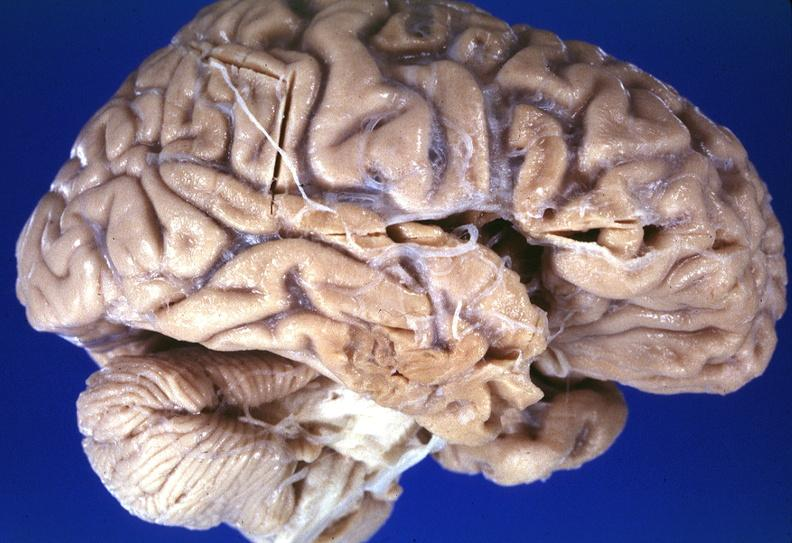does this image show brain, frontal lobe atrophy, pick 's disease?
Answer the question using a single word or phrase. Yes 